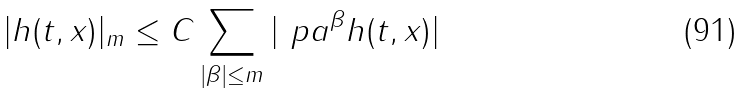Convert formula to latex. <formula><loc_0><loc_0><loc_500><loc_500>| h ( t , x ) | _ { m } \leq C \sum _ { | \beta | \leq m } | \ p a ^ { \beta } h ( t , x ) |</formula> 